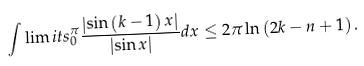<formula> <loc_0><loc_0><loc_500><loc_500>\int \lim i t s _ { 0 } ^ { \pi } \frac { \left | \sin \left ( k - 1 \right ) x \right | } { \left | \sin x \right | } d x \leq 2 \pi \ln \left ( 2 k - n + 1 \right ) .</formula> 